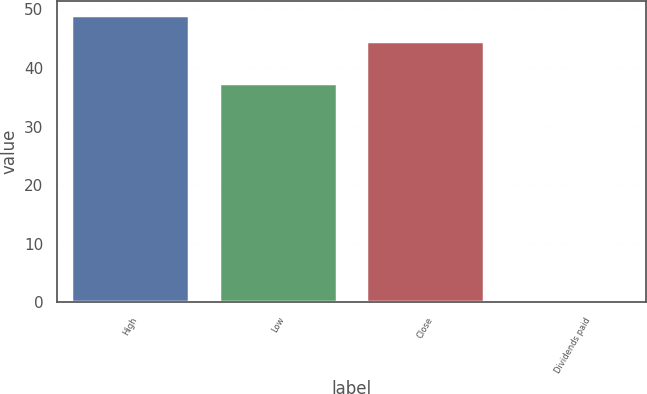<chart> <loc_0><loc_0><loc_500><loc_500><bar_chart><fcel>High<fcel>Low<fcel>Close<fcel>Dividends paid<nl><fcel>49.01<fcel>37.43<fcel>44.51<fcel>0.22<nl></chart> 